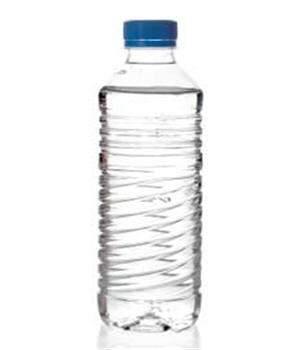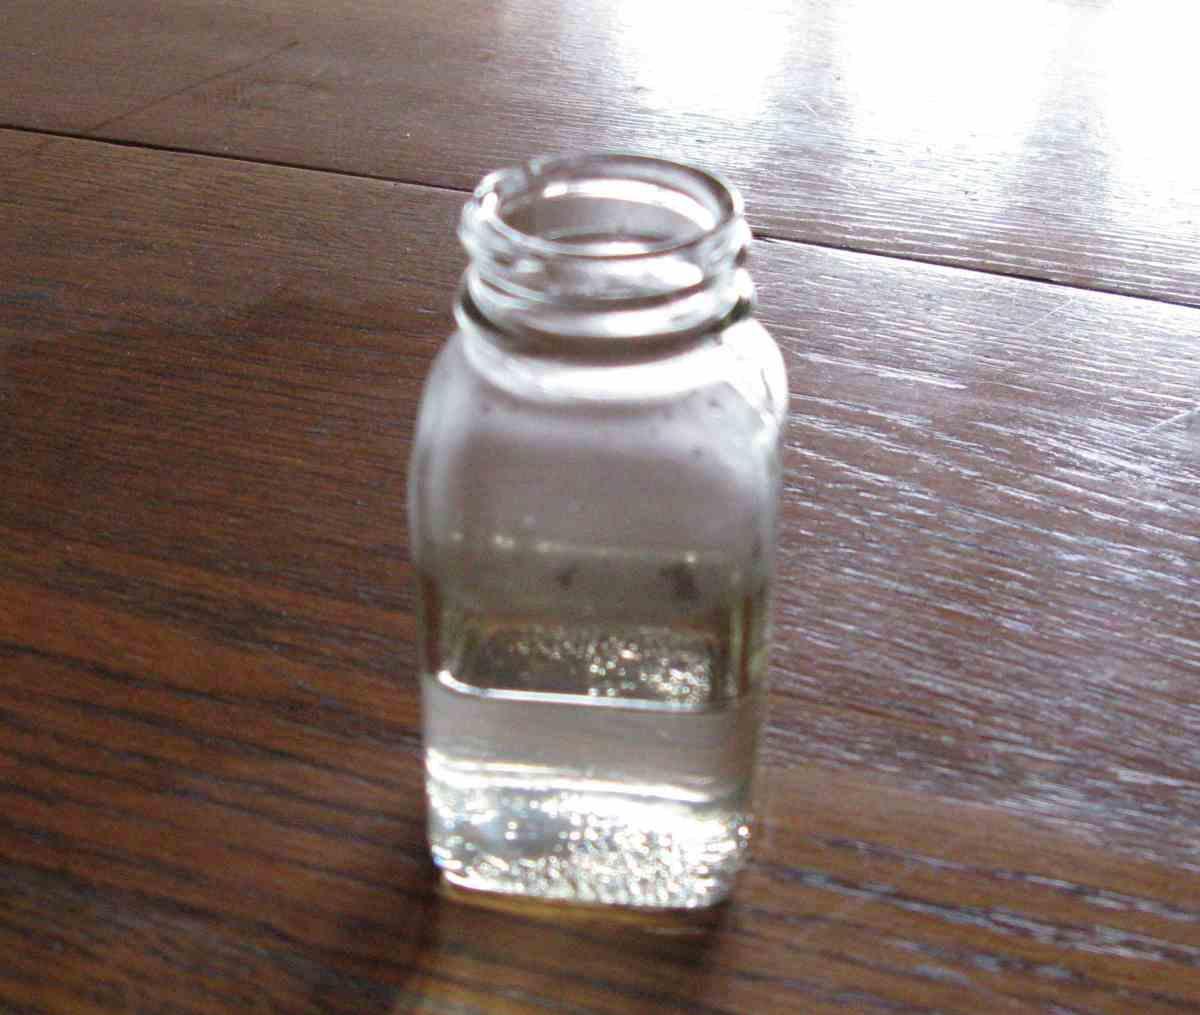The first image is the image on the left, the second image is the image on the right. Considering the images on both sides, is "There are three or more plastic water bottles in total." valid? Answer yes or no. No. 